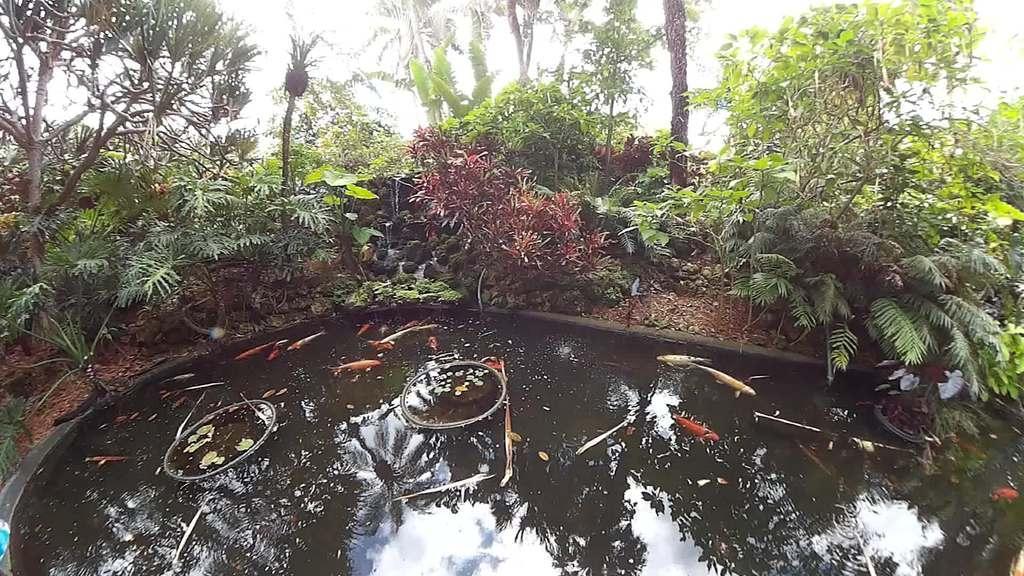Can you describe this image briefly? In this image at the bottom there is small pond, and there are some fishes in that pond. In the background there are some trees and plants. 